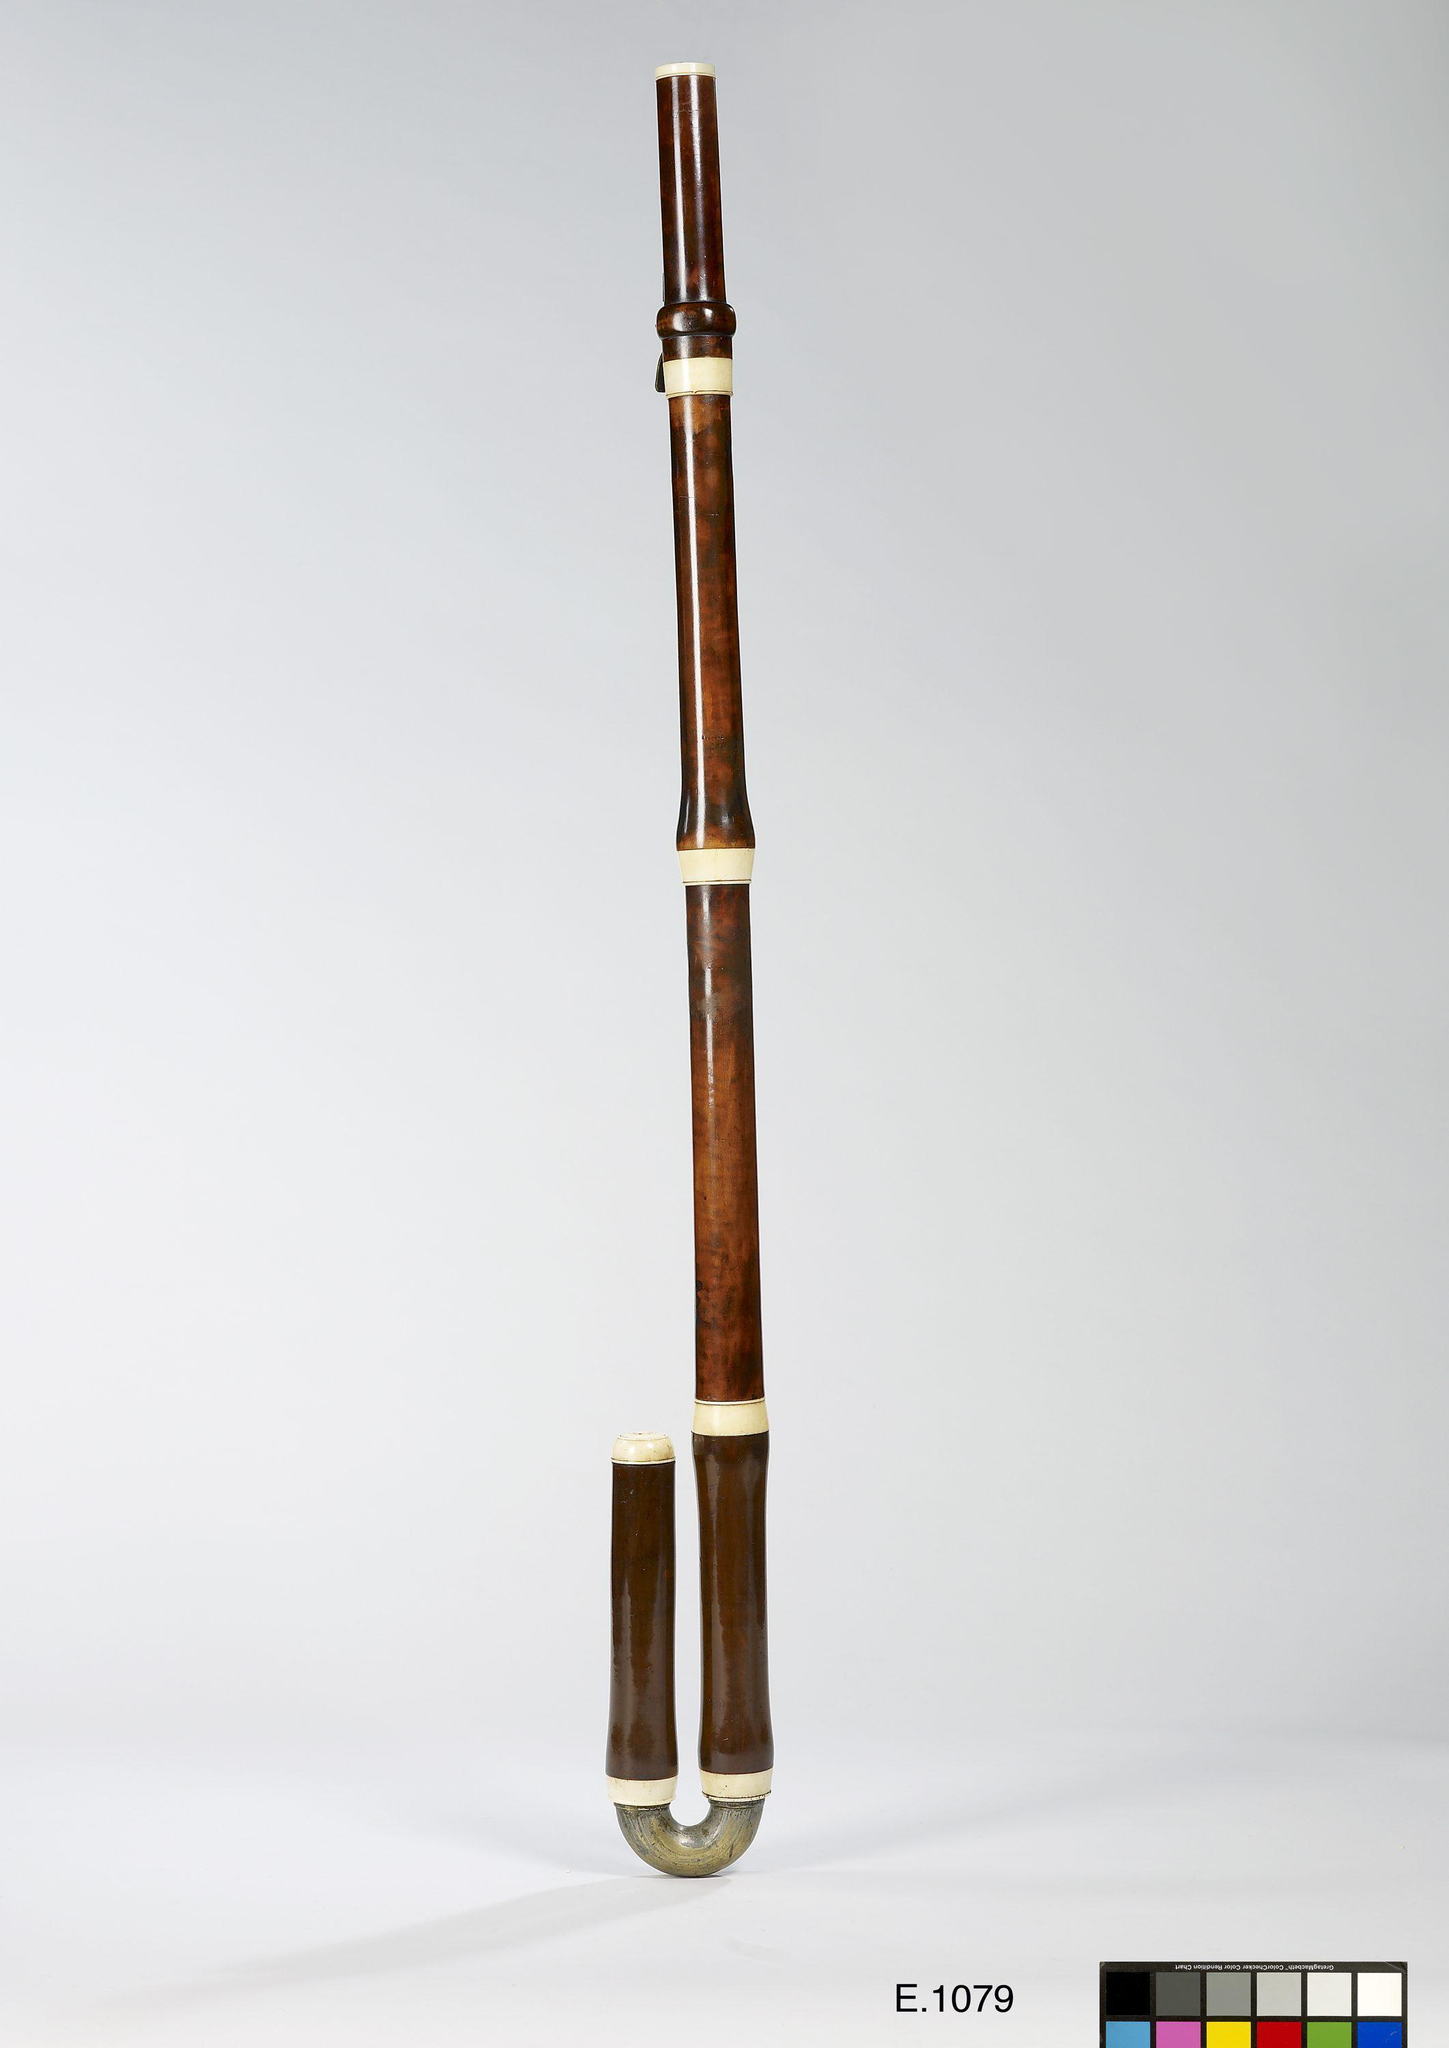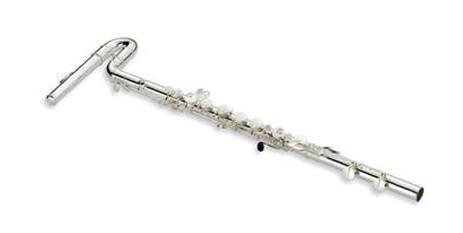The first image is the image on the left, the second image is the image on the right. Given the left and right images, does the statement "There are two curved head flutes." hold true? Answer yes or no. Yes. The first image is the image on the left, the second image is the image on the right. For the images displayed, is the sentence "The left and right image contains the same number of hooked flutes." factually correct? Answer yes or no. Yes. 